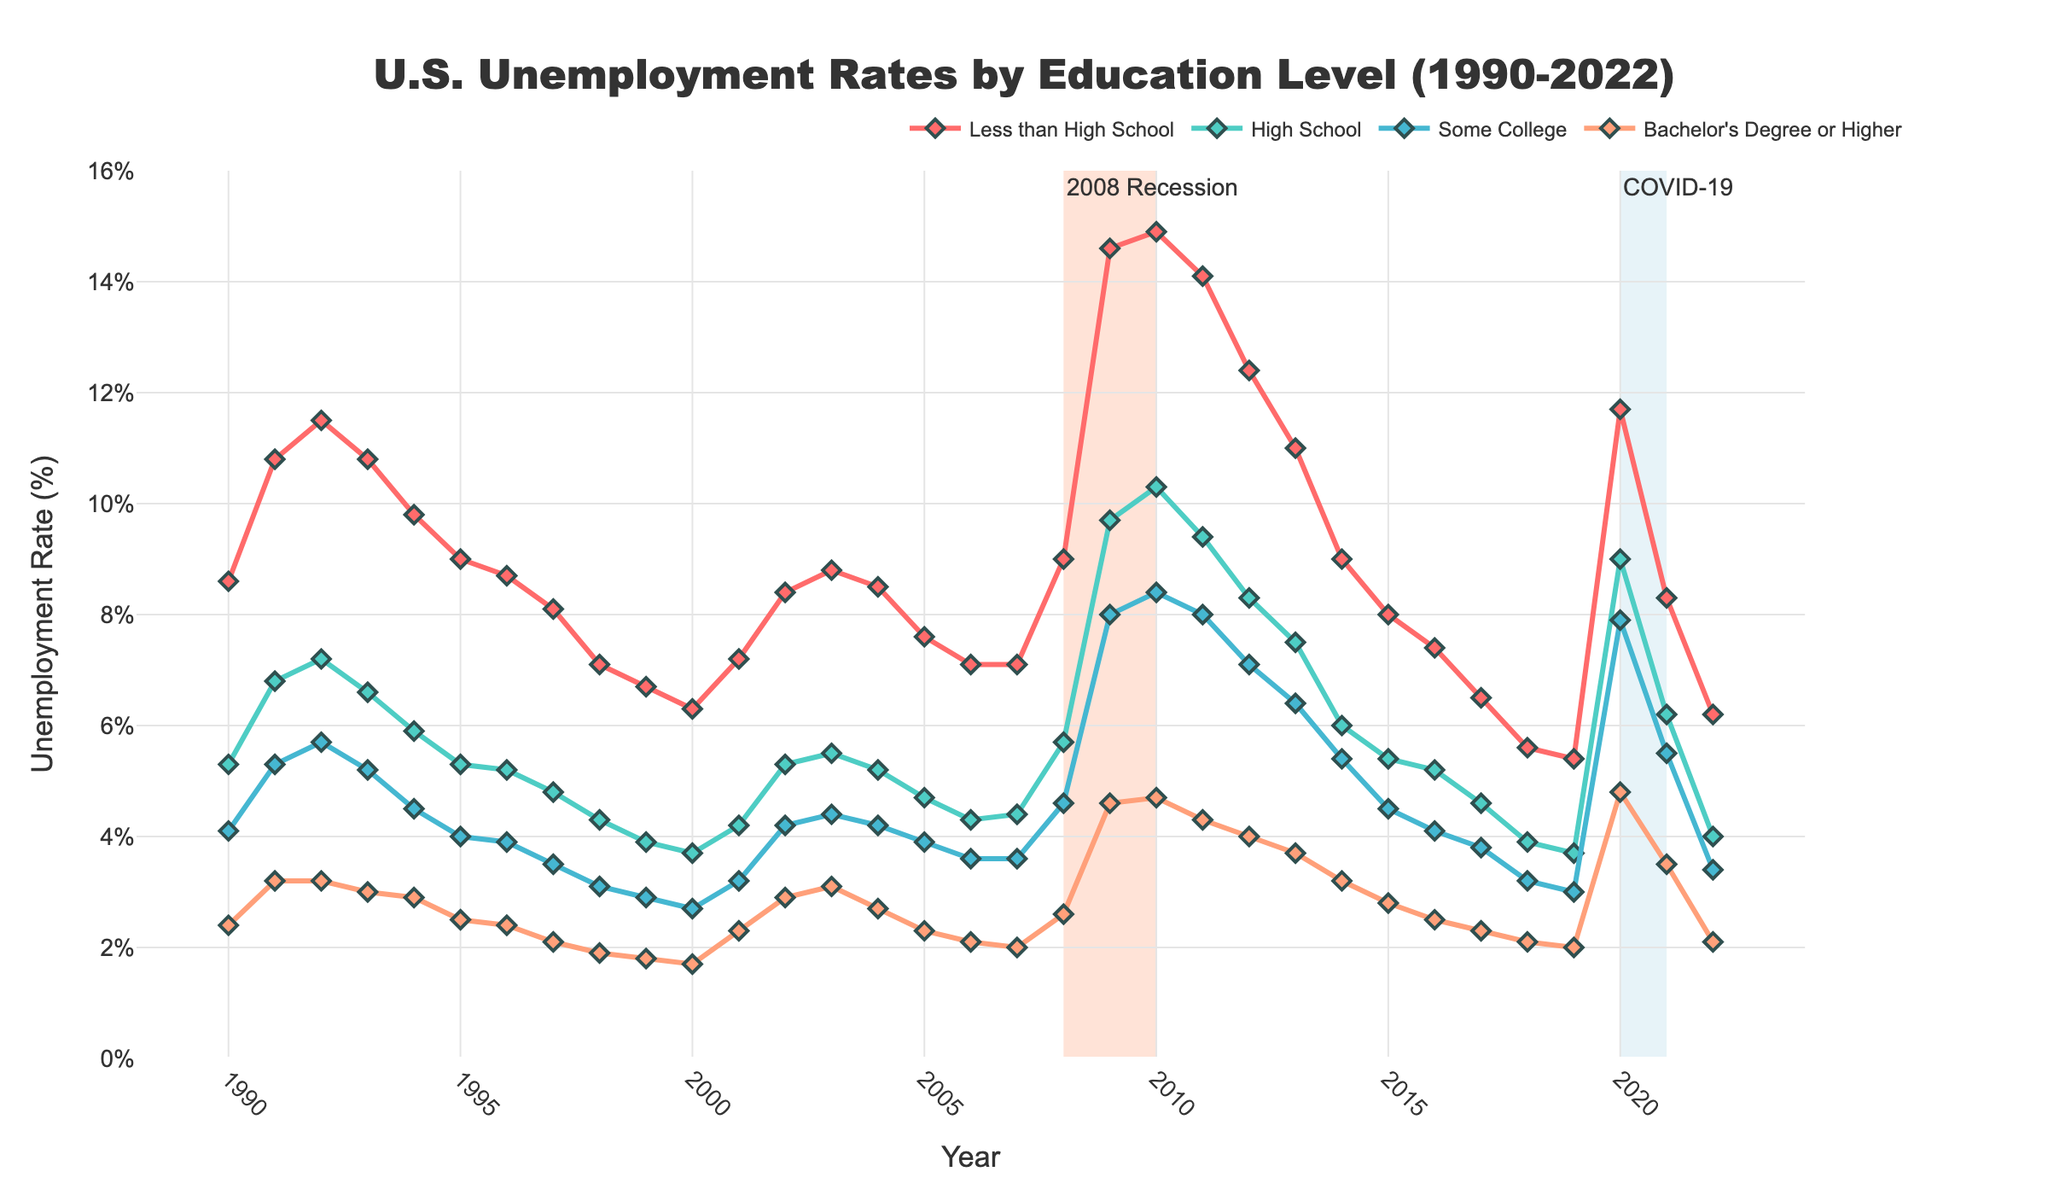What's the highest unemployment rate for those with less than a high school education, and in which year did it occur? The highest unemployment rate for individuals with less than a high school education can be determined by examining the peak point of the red line, which is around 14.9% in 2010.
Answer: 14.9% in 2010 How did the unemployment rate for individuals with a Bachelor’s Degree or higher change between the years of 2008 and 2010? Refer to the green line and compare the values at 2008 and 2010. The unemployment rate increased from 2.6% in 2008 to 4.7% in 2010.
Answer: Increased from 2.6% to 4.7% During which periods did the unemployment rates for all education levels increase? Look for periods where all lines move upward together. Notable periods include 2008-2010 and 2020-2021.
Answer: 2008-2010 and 2020-2021 Compare the unemployment rates of individuals with "Some College" education and "High School" education in 2020. Refer to the positions of the pink and teal lines in 2020. The unemployment rate for "Some College" is approximately 7.9%, while for "High School" it is around 9.0%.
Answer: Some College: 7.9%, High School: 9.0% What's the difference in unemployment rates between those with a high school diploma and those with a bachelor's degree or higher in 2009? Subtract the unemployment rate of Bachelor's Degree or Higher (4.6%) from that of High School (9.7%) for 2009. The difference is 9.7% - 4.6% = 5.1%.
Answer: 5.1% What education level had the lowest unemployment rate in 1998 and what was the rate? Identify the lowest point among the markers for all lines in 1998. The blue line representing Bachelor's Degree or Higher has the lowest rate at 1.9%.
Answer: Bachelor’s Degree or Higher, 1.9% Determine the average unemployment rate for individuals with some college education during the 2001-2005 period. Sum the unemployment rates from 2001 to 2005 (3.2%, 4.2%, 4.4%, 4.2%, 3.9%) and divide by 5. (3.2 + 4.2 + 4.4 + 4.2 + 3.9) / 5 = 3.98%.
Answer: 3.98% What is the visual indication of significant economic events on the chart? Look for the shaded areas and annotations. Two key events are marked: the 2008 Recession with a pink shaded area and "2008 Recession" annotation, and the COVID-19 period with a blue shaded area and "COVID-19" annotation.
Answer: Shaded areas and annotations Between 1990 to 2000, which education level saw the greatest overall decrease in unemployment rate, and by how much? Calculate the difference in unemployment rates between 1990 and 2000 for each education level. The greatest decrease is for 'Less than High School' from 8.6% to 6.3%, a reduction of 2.3%.
Answer: Less than High School, 2.3% 